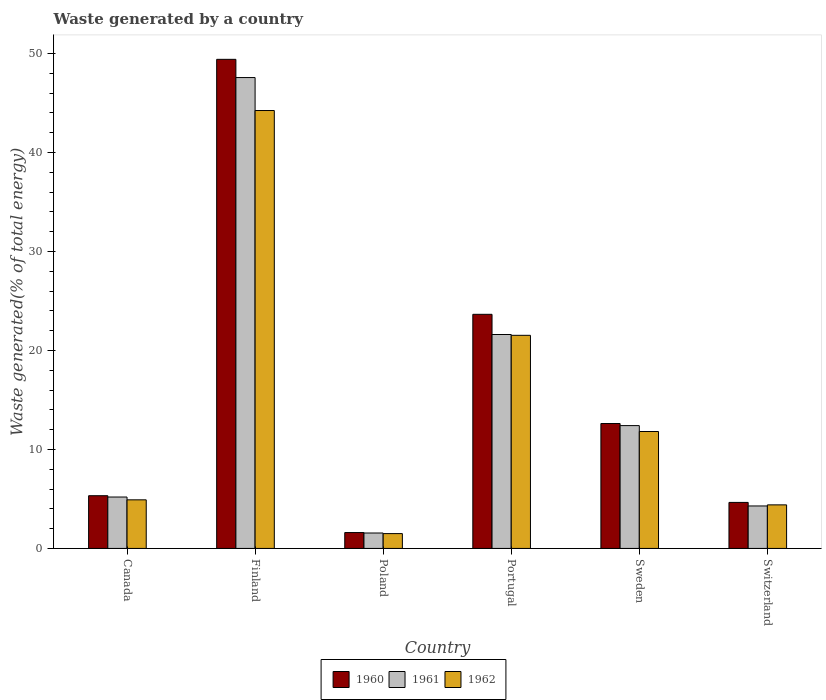How many different coloured bars are there?
Your response must be concise. 3. How many groups of bars are there?
Offer a terse response. 6. Are the number of bars per tick equal to the number of legend labels?
Provide a short and direct response. Yes. How many bars are there on the 2nd tick from the left?
Your answer should be very brief. 3. What is the label of the 1st group of bars from the left?
Ensure brevity in your answer.  Canada. In how many cases, is the number of bars for a given country not equal to the number of legend labels?
Your answer should be very brief. 0. What is the total waste generated in 1961 in Poland?
Offer a very short reply. 1.56. Across all countries, what is the maximum total waste generated in 1961?
Ensure brevity in your answer.  47.58. Across all countries, what is the minimum total waste generated in 1960?
Offer a terse response. 1.6. In which country was the total waste generated in 1961 maximum?
Offer a terse response. Finland. In which country was the total waste generated in 1962 minimum?
Give a very brief answer. Poland. What is the total total waste generated in 1962 in the graph?
Offer a very short reply. 88.41. What is the difference between the total waste generated in 1961 in Finland and that in Portugal?
Provide a succinct answer. 25.96. What is the difference between the total waste generated in 1960 in Poland and the total waste generated in 1962 in Switzerland?
Keep it short and to the point. -2.8. What is the average total waste generated in 1961 per country?
Provide a succinct answer. 15.44. What is the difference between the total waste generated of/in 1961 and total waste generated of/in 1960 in Sweden?
Make the answer very short. -0.21. What is the ratio of the total waste generated in 1961 in Canada to that in Portugal?
Your response must be concise. 0.24. What is the difference between the highest and the second highest total waste generated in 1961?
Your answer should be very brief. -9.2. What is the difference between the highest and the lowest total waste generated in 1962?
Ensure brevity in your answer.  42.75. In how many countries, is the total waste generated in 1962 greater than the average total waste generated in 1962 taken over all countries?
Give a very brief answer. 2. What does the 3rd bar from the left in Canada represents?
Offer a very short reply. 1962. What does the 2nd bar from the right in Canada represents?
Ensure brevity in your answer.  1961. Is it the case that in every country, the sum of the total waste generated in 1960 and total waste generated in 1961 is greater than the total waste generated in 1962?
Provide a succinct answer. Yes. How many bars are there?
Make the answer very short. 18. Are all the bars in the graph horizontal?
Offer a very short reply. No. How many countries are there in the graph?
Ensure brevity in your answer.  6. What is the difference between two consecutive major ticks on the Y-axis?
Give a very brief answer. 10. Are the values on the major ticks of Y-axis written in scientific E-notation?
Ensure brevity in your answer.  No. Does the graph contain any zero values?
Your answer should be compact. No. What is the title of the graph?
Provide a short and direct response. Waste generated by a country. Does "2006" appear as one of the legend labels in the graph?
Ensure brevity in your answer.  No. What is the label or title of the X-axis?
Your response must be concise. Country. What is the label or title of the Y-axis?
Keep it short and to the point. Waste generated(% of total energy). What is the Waste generated(% of total energy) of 1960 in Canada?
Your answer should be compact. 5.33. What is the Waste generated(% of total energy) in 1961 in Canada?
Offer a terse response. 5.19. What is the Waste generated(% of total energy) of 1962 in Canada?
Provide a succinct answer. 4.91. What is the Waste generated(% of total energy) in 1960 in Finland?
Your answer should be compact. 49.42. What is the Waste generated(% of total energy) of 1961 in Finland?
Offer a terse response. 47.58. What is the Waste generated(% of total energy) in 1962 in Finland?
Keep it short and to the point. 44.25. What is the Waste generated(% of total energy) in 1960 in Poland?
Ensure brevity in your answer.  1.6. What is the Waste generated(% of total energy) of 1961 in Poland?
Make the answer very short. 1.56. What is the Waste generated(% of total energy) in 1962 in Poland?
Keep it short and to the point. 1.5. What is the Waste generated(% of total energy) in 1960 in Portugal?
Give a very brief answer. 23.66. What is the Waste generated(% of total energy) in 1961 in Portugal?
Provide a succinct answer. 21.62. What is the Waste generated(% of total energy) of 1962 in Portugal?
Give a very brief answer. 21.53. What is the Waste generated(% of total energy) in 1960 in Sweden?
Provide a short and direct response. 12.62. What is the Waste generated(% of total energy) in 1961 in Sweden?
Offer a terse response. 12.41. What is the Waste generated(% of total energy) of 1962 in Sweden?
Ensure brevity in your answer.  11.82. What is the Waste generated(% of total energy) in 1960 in Switzerland?
Offer a terse response. 4.65. What is the Waste generated(% of total energy) in 1961 in Switzerland?
Provide a succinct answer. 4.29. What is the Waste generated(% of total energy) in 1962 in Switzerland?
Your answer should be very brief. 4.4. Across all countries, what is the maximum Waste generated(% of total energy) in 1960?
Your answer should be very brief. 49.42. Across all countries, what is the maximum Waste generated(% of total energy) of 1961?
Your answer should be very brief. 47.58. Across all countries, what is the maximum Waste generated(% of total energy) in 1962?
Your answer should be very brief. 44.25. Across all countries, what is the minimum Waste generated(% of total energy) in 1960?
Your answer should be very brief. 1.6. Across all countries, what is the minimum Waste generated(% of total energy) in 1961?
Ensure brevity in your answer.  1.56. Across all countries, what is the minimum Waste generated(% of total energy) of 1962?
Your response must be concise. 1.5. What is the total Waste generated(% of total energy) in 1960 in the graph?
Give a very brief answer. 97.28. What is the total Waste generated(% of total energy) of 1961 in the graph?
Make the answer very short. 92.66. What is the total Waste generated(% of total energy) in 1962 in the graph?
Offer a terse response. 88.41. What is the difference between the Waste generated(% of total energy) in 1960 in Canada and that in Finland?
Provide a short and direct response. -44.1. What is the difference between the Waste generated(% of total energy) of 1961 in Canada and that in Finland?
Provide a succinct answer. -42.39. What is the difference between the Waste generated(% of total energy) of 1962 in Canada and that in Finland?
Make the answer very short. -39.34. What is the difference between the Waste generated(% of total energy) of 1960 in Canada and that in Poland?
Provide a short and direct response. 3.72. What is the difference between the Waste generated(% of total energy) of 1961 in Canada and that in Poland?
Provide a succinct answer. 3.64. What is the difference between the Waste generated(% of total energy) of 1962 in Canada and that in Poland?
Keep it short and to the point. 3.41. What is the difference between the Waste generated(% of total energy) in 1960 in Canada and that in Portugal?
Your response must be concise. -18.33. What is the difference between the Waste generated(% of total energy) in 1961 in Canada and that in Portugal?
Offer a very short reply. -16.42. What is the difference between the Waste generated(% of total energy) of 1962 in Canada and that in Portugal?
Your answer should be compact. -16.62. What is the difference between the Waste generated(% of total energy) in 1960 in Canada and that in Sweden?
Your answer should be compact. -7.29. What is the difference between the Waste generated(% of total energy) in 1961 in Canada and that in Sweden?
Provide a short and direct response. -7.22. What is the difference between the Waste generated(% of total energy) in 1962 in Canada and that in Sweden?
Provide a short and direct response. -6.9. What is the difference between the Waste generated(% of total energy) of 1960 in Canada and that in Switzerland?
Your answer should be very brief. 0.68. What is the difference between the Waste generated(% of total energy) in 1961 in Canada and that in Switzerland?
Make the answer very short. 0.9. What is the difference between the Waste generated(% of total energy) of 1962 in Canada and that in Switzerland?
Your response must be concise. 0.51. What is the difference between the Waste generated(% of total energy) of 1960 in Finland and that in Poland?
Offer a terse response. 47.82. What is the difference between the Waste generated(% of total energy) in 1961 in Finland and that in Poland?
Keep it short and to the point. 46.02. What is the difference between the Waste generated(% of total energy) in 1962 in Finland and that in Poland?
Your answer should be compact. 42.75. What is the difference between the Waste generated(% of total energy) of 1960 in Finland and that in Portugal?
Keep it short and to the point. 25.77. What is the difference between the Waste generated(% of total energy) in 1961 in Finland and that in Portugal?
Keep it short and to the point. 25.96. What is the difference between the Waste generated(% of total energy) in 1962 in Finland and that in Portugal?
Make the answer very short. 22.72. What is the difference between the Waste generated(% of total energy) of 1960 in Finland and that in Sweden?
Provide a short and direct response. 36.8. What is the difference between the Waste generated(% of total energy) of 1961 in Finland and that in Sweden?
Provide a succinct answer. 35.17. What is the difference between the Waste generated(% of total energy) of 1962 in Finland and that in Sweden?
Your answer should be very brief. 32.44. What is the difference between the Waste generated(% of total energy) in 1960 in Finland and that in Switzerland?
Your answer should be very brief. 44.77. What is the difference between the Waste generated(% of total energy) of 1961 in Finland and that in Switzerland?
Give a very brief answer. 43.29. What is the difference between the Waste generated(% of total energy) of 1962 in Finland and that in Switzerland?
Keep it short and to the point. 39.85. What is the difference between the Waste generated(% of total energy) of 1960 in Poland and that in Portugal?
Your response must be concise. -22.05. What is the difference between the Waste generated(% of total energy) of 1961 in Poland and that in Portugal?
Ensure brevity in your answer.  -20.06. What is the difference between the Waste generated(% of total energy) in 1962 in Poland and that in Portugal?
Provide a succinct answer. -20.03. What is the difference between the Waste generated(% of total energy) in 1960 in Poland and that in Sweden?
Ensure brevity in your answer.  -11.02. What is the difference between the Waste generated(% of total energy) in 1961 in Poland and that in Sweden?
Ensure brevity in your answer.  -10.85. What is the difference between the Waste generated(% of total energy) in 1962 in Poland and that in Sweden?
Keep it short and to the point. -10.32. What is the difference between the Waste generated(% of total energy) in 1960 in Poland and that in Switzerland?
Your answer should be compact. -3.04. What is the difference between the Waste generated(% of total energy) of 1961 in Poland and that in Switzerland?
Give a very brief answer. -2.73. What is the difference between the Waste generated(% of total energy) of 1962 in Poland and that in Switzerland?
Ensure brevity in your answer.  -2.9. What is the difference between the Waste generated(% of total energy) of 1960 in Portugal and that in Sweden?
Offer a very short reply. 11.03. What is the difference between the Waste generated(% of total energy) of 1961 in Portugal and that in Sweden?
Make the answer very short. 9.2. What is the difference between the Waste generated(% of total energy) of 1962 in Portugal and that in Sweden?
Give a very brief answer. 9.72. What is the difference between the Waste generated(% of total energy) in 1960 in Portugal and that in Switzerland?
Provide a succinct answer. 19.01. What is the difference between the Waste generated(% of total energy) in 1961 in Portugal and that in Switzerland?
Make the answer very short. 17.32. What is the difference between the Waste generated(% of total energy) of 1962 in Portugal and that in Switzerland?
Give a very brief answer. 17.13. What is the difference between the Waste generated(% of total energy) in 1960 in Sweden and that in Switzerland?
Your answer should be compact. 7.97. What is the difference between the Waste generated(% of total energy) in 1961 in Sweden and that in Switzerland?
Your response must be concise. 8.12. What is the difference between the Waste generated(% of total energy) of 1962 in Sweden and that in Switzerland?
Provide a succinct answer. 7.41. What is the difference between the Waste generated(% of total energy) of 1960 in Canada and the Waste generated(% of total energy) of 1961 in Finland?
Your answer should be compact. -42.25. What is the difference between the Waste generated(% of total energy) in 1960 in Canada and the Waste generated(% of total energy) in 1962 in Finland?
Provide a succinct answer. -38.92. What is the difference between the Waste generated(% of total energy) in 1961 in Canada and the Waste generated(% of total energy) in 1962 in Finland?
Give a very brief answer. -39.06. What is the difference between the Waste generated(% of total energy) in 1960 in Canada and the Waste generated(% of total energy) in 1961 in Poland?
Offer a terse response. 3.77. What is the difference between the Waste generated(% of total energy) in 1960 in Canada and the Waste generated(% of total energy) in 1962 in Poland?
Offer a terse response. 3.83. What is the difference between the Waste generated(% of total energy) in 1961 in Canada and the Waste generated(% of total energy) in 1962 in Poland?
Make the answer very short. 3.7. What is the difference between the Waste generated(% of total energy) in 1960 in Canada and the Waste generated(% of total energy) in 1961 in Portugal?
Provide a short and direct response. -16.29. What is the difference between the Waste generated(% of total energy) in 1960 in Canada and the Waste generated(% of total energy) in 1962 in Portugal?
Offer a very short reply. -16.21. What is the difference between the Waste generated(% of total energy) of 1961 in Canada and the Waste generated(% of total energy) of 1962 in Portugal?
Offer a terse response. -16.34. What is the difference between the Waste generated(% of total energy) of 1960 in Canada and the Waste generated(% of total energy) of 1961 in Sweden?
Offer a terse response. -7.08. What is the difference between the Waste generated(% of total energy) in 1960 in Canada and the Waste generated(% of total energy) in 1962 in Sweden?
Provide a succinct answer. -6.49. What is the difference between the Waste generated(% of total energy) of 1961 in Canada and the Waste generated(% of total energy) of 1962 in Sweden?
Make the answer very short. -6.62. What is the difference between the Waste generated(% of total energy) in 1960 in Canada and the Waste generated(% of total energy) in 1961 in Switzerland?
Make the answer very short. 1.04. What is the difference between the Waste generated(% of total energy) in 1960 in Canada and the Waste generated(% of total energy) in 1962 in Switzerland?
Offer a terse response. 0.93. What is the difference between the Waste generated(% of total energy) in 1961 in Canada and the Waste generated(% of total energy) in 1962 in Switzerland?
Your response must be concise. 0.79. What is the difference between the Waste generated(% of total energy) of 1960 in Finland and the Waste generated(% of total energy) of 1961 in Poland?
Offer a terse response. 47.86. What is the difference between the Waste generated(% of total energy) of 1960 in Finland and the Waste generated(% of total energy) of 1962 in Poland?
Ensure brevity in your answer.  47.92. What is the difference between the Waste generated(% of total energy) of 1961 in Finland and the Waste generated(% of total energy) of 1962 in Poland?
Ensure brevity in your answer.  46.08. What is the difference between the Waste generated(% of total energy) of 1960 in Finland and the Waste generated(% of total energy) of 1961 in Portugal?
Your response must be concise. 27.81. What is the difference between the Waste generated(% of total energy) in 1960 in Finland and the Waste generated(% of total energy) in 1962 in Portugal?
Offer a terse response. 27.89. What is the difference between the Waste generated(% of total energy) in 1961 in Finland and the Waste generated(% of total energy) in 1962 in Portugal?
Your answer should be compact. 26.05. What is the difference between the Waste generated(% of total energy) of 1960 in Finland and the Waste generated(% of total energy) of 1961 in Sweden?
Ensure brevity in your answer.  37.01. What is the difference between the Waste generated(% of total energy) of 1960 in Finland and the Waste generated(% of total energy) of 1962 in Sweden?
Provide a succinct answer. 37.61. What is the difference between the Waste generated(% of total energy) in 1961 in Finland and the Waste generated(% of total energy) in 1962 in Sweden?
Offer a terse response. 35.77. What is the difference between the Waste generated(% of total energy) of 1960 in Finland and the Waste generated(% of total energy) of 1961 in Switzerland?
Ensure brevity in your answer.  45.13. What is the difference between the Waste generated(% of total energy) of 1960 in Finland and the Waste generated(% of total energy) of 1962 in Switzerland?
Your response must be concise. 45.02. What is the difference between the Waste generated(% of total energy) in 1961 in Finland and the Waste generated(% of total energy) in 1962 in Switzerland?
Offer a very short reply. 43.18. What is the difference between the Waste generated(% of total energy) of 1960 in Poland and the Waste generated(% of total energy) of 1961 in Portugal?
Give a very brief answer. -20.01. What is the difference between the Waste generated(% of total energy) in 1960 in Poland and the Waste generated(% of total energy) in 1962 in Portugal?
Offer a very short reply. -19.93. What is the difference between the Waste generated(% of total energy) of 1961 in Poland and the Waste generated(% of total energy) of 1962 in Portugal?
Provide a short and direct response. -19.98. What is the difference between the Waste generated(% of total energy) in 1960 in Poland and the Waste generated(% of total energy) in 1961 in Sweden?
Provide a short and direct response. -10.81. What is the difference between the Waste generated(% of total energy) of 1960 in Poland and the Waste generated(% of total energy) of 1962 in Sweden?
Your response must be concise. -10.21. What is the difference between the Waste generated(% of total energy) of 1961 in Poland and the Waste generated(% of total energy) of 1962 in Sweden?
Keep it short and to the point. -10.26. What is the difference between the Waste generated(% of total energy) of 1960 in Poland and the Waste generated(% of total energy) of 1961 in Switzerland?
Offer a very short reply. -2.69. What is the difference between the Waste generated(% of total energy) in 1960 in Poland and the Waste generated(% of total energy) in 1962 in Switzerland?
Offer a terse response. -2.8. What is the difference between the Waste generated(% of total energy) in 1961 in Poland and the Waste generated(% of total energy) in 1962 in Switzerland?
Offer a very short reply. -2.84. What is the difference between the Waste generated(% of total energy) in 1960 in Portugal and the Waste generated(% of total energy) in 1961 in Sweden?
Offer a very short reply. 11.24. What is the difference between the Waste generated(% of total energy) of 1960 in Portugal and the Waste generated(% of total energy) of 1962 in Sweden?
Offer a terse response. 11.84. What is the difference between the Waste generated(% of total energy) in 1961 in Portugal and the Waste generated(% of total energy) in 1962 in Sweden?
Ensure brevity in your answer.  9.8. What is the difference between the Waste generated(% of total energy) in 1960 in Portugal and the Waste generated(% of total energy) in 1961 in Switzerland?
Ensure brevity in your answer.  19.36. What is the difference between the Waste generated(% of total energy) of 1960 in Portugal and the Waste generated(% of total energy) of 1962 in Switzerland?
Provide a succinct answer. 19.25. What is the difference between the Waste generated(% of total energy) of 1961 in Portugal and the Waste generated(% of total energy) of 1962 in Switzerland?
Give a very brief answer. 17.21. What is the difference between the Waste generated(% of total energy) in 1960 in Sweden and the Waste generated(% of total energy) in 1961 in Switzerland?
Your answer should be compact. 8.33. What is the difference between the Waste generated(% of total energy) in 1960 in Sweden and the Waste generated(% of total energy) in 1962 in Switzerland?
Offer a very short reply. 8.22. What is the difference between the Waste generated(% of total energy) in 1961 in Sweden and the Waste generated(% of total energy) in 1962 in Switzerland?
Provide a short and direct response. 8.01. What is the average Waste generated(% of total energy) of 1960 per country?
Offer a very short reply. 16.21. What is the average Waste generated(% of total energy) of 1961 per country?
Provide a succinct answer. 15.44. What is the average Waste generated(% of total energy) of 1962 per country?
Give a very brief answer. 14.74. What is the difference between the Waste generated(% of total energy) in 1960 and Waste generated(% of total energy) in 1961 in Canada?
Offer a terse response. 0.13. What is the difference between the Waste generated(% of total energy) of 1960 and Waste generated(% of total energy) of 1962 in Canada?
Ensure brevity in your answer.  0.42. What is the difference between the Waste generated(% of total energy) of 1961 and Waste generated(% of total energy) of 1962 in Canada?
Provide a short and direct response. 0.28. What is the difference between the Waste generated(% of total energy) in 1960 and Waste generated(% of total energy) in 1961 in Finland?
Offer a terse response. 1.84. What is the difference between the Waste generated(% of total energy) in 1960 and Waste generated(% of total energy) in 1962 in Finland?
Offer a very short reply. 5.17. What is the difference between the Waste generated(% of total energy) in 1961 and Waste generated(% of total energy) in 1962 in Finland?
Give a very brief answer. 3.33. What is the difference between the Waste generated(% of total energy) in 1960 and Waste generated(% of total energy) in 1961 in Poland?
Offer a terse response. 0.05. What is the difference between the Waste generated(% of total energy) of 1960 and Waste generated(% of total energy) of 1962 in Poland?
Provide a short and direct response. 0.11. What is the difference between the Waste generated(% of total energy) of 1961 and Waste generated(% of total energy) of 1962 in Poland?
Your answer should be very brief. 0.06. What is the difference between the Waste generated(% of total energy) in 1960 and Waste generated(% of total energy) in 1961 in Portugal?
Your answer should be very brief. 2.04. What is the difference between the Waste generated(% of total energy) of 1960 and Waste generated(% of total energy) of 1962 in Portugal?
Offer a terse response. 2.12. What is the difference between the Waste generated(% of total energy) in 1961 and Waste generated(% of total energy) in 1962 in Portugal?
Keep it short and to the point. 0.08. What is the difference between the Waste generated(% of total energy) of 1960 and Waste generated(% of total energy) of 1961 in Sweden?
Offer a very short reply. 0.21. What is the difference between the Waste generated(% of total energy) in 1960 and Waste generated(% of total energy) in 1962 in Sweden?
Give a very brief answer. 0.81. What is the difference between the Waste generated(% of total energy) of 1961 and Waste generated(% of total energy) of 1962 in Sweden?
Make the answer very short. 0.6. What is the difference between the Waste generated(% of total energy) of 1960 and Waste generated(% of total energy) of 1961 in Switzerland?
Your answer should be compact. 0.36. What is the difference between the Waste generated(% of total energy) of 1960 and Waste generated(% of total energy) of 1962 in Switzerland?
Your answer should be very brief. 0.25. What is the difference between the Waste generated(% of total energy) in 1961 and Waste generated(% of total energy) in 1962 in Switzerland?
Offer a terse response. -0.11. What is the ratio of the Waste generated(% of total energy) of 1960 in Canada to that in Finland?
Provide a succinct answer. 0.11. What is the ratio of the Waste generated(% of total energy) in 1961 in Canada to that in Finland?
Offer a terse response. 0.11. What is the ratio of the Waste generated(% of total energy) of 1962 in Canada to that in Finland?
Offer a very short reply. 0.11. What is the ratio of the Waste generated(% of total energy) of 1960 in Canada to that in Poland?
Keep it short and to the point. 3.32. What is the ratio of the Waste generated(% of total energy) of 1961 in Canada to that in Poland?
Provide a succinct answer. 3.33. What is the ratio of the Waste generated(% of total energy) of 1962 in Canada to that in Poland?
Your response must be concise. 3.28. What is the ratio of the Waste generated(% of total energy) of 1960 in Canada to that in Portugal?
Make the answer very short. 0.23. What is the ratio of the Waste generated(% of total energy) in 1961 in Canada to that in Portugal?
Provide a succinct answer. 0.24. What is the ratio of the Waste generated(% of total energy) in 1962 in Canada to that in Portugal?
Ensure brevity in your answer.  0.23. What is the ratio of the Waste generated(% of total energy) of 1960 in Canada to that in Sweden?
Offer a terse response. 0.42. What is the ratio of the Waste generated(% of total energy) of 1961 in Canada to that in Sweden?
Give a very brief answer. 0.42. What is the ratio of the Waste generated(% of total energy) in 1962 in Canada to that in Sweden?
Keep it short and to the point. 0.42. What is the ratio of the Waste generated(% of total energy) in 1960 in Canada to that in Switzerland?
Your answer should be compact. 1.15. What is the ratio of the Waste generated(% of total energy) of 1961 in Canada to that in Switzerland?
Give a very brief answer. 1.21. What is the ratio of the Waste generated(% of total energy) of 1962 in Canada to that in Switzerland?
Make the answer very short. 1.12. What is the ratio of the Waste generated(% of total energy) of 1960 in Finland to that in Poland?
Offer a very short reply. 30.8. What is the ratio of the Waste generated(% of total energy) of 1961 in Finland to that in Poland?
Give a very brief answer. 30.53. What is the ratio of the Waste generated(% of total energy) in 1962 in Finland to that in Poland?
Offer a very short reply. 29.52. What is the ratio of the Waste generated(% of total energy) of 1960 in Finland to that in Portugal?
Give a very brief answer. 2.09. What is the ratio of the Waste generated(% of total energy) of 1961 in Finland to that in Portugal?
Provide a succinct answer. 2.2. What is the ratio of the Waste generated(% of total energy) of 1962 in Finland to that in Portugal?
Your answer should be compact. 2.05. What is the ratio of the Waste generated(% of total energy) in 1960 in Finland to that in Sweden?
Keep it short and to the point. 3.92. What is the ratio of the Waste generated(% of total energy) of 1961 in Finland to that in Sweden?
Provide a short and direct response. 3.83. What is the ratio of the Waste generated(% of total energy) of 1962 in Finland to that in Sweden?
Make the answer very short. 3.75. What is the ratio of the Waste generated(% of total energy) of 1960 in Finland to that in Switzerland?
Make the answer very short. 10.63. What is the ratio of the Waste generated(% of total energy) in 1961 in Finland to that in Switzerland?
Your answer should be compact. 11.09. What is the ratio of the Waste generated(% of total energy) of 1962 in Finland to that in Switzerland?
Give a very brief answer. 10.05. What is the ratio of the Waste generated(% of total energy) of 1960 in Poland to that in Portugal?
Make the answer very short. 0.07. What is the ratio of the Waste generated(% of total energy) of 1961 in Poland to that in Portugal?
Provide a short and direct response. 0.07. What is the ratio of the Waste generated(% of total energy) of 1962 in Poland to that in Portugal?
Your answer should be very brief. 0.07. What is the ratio of the Waste generated(% of total energy) in 1960 in Poland to that in Sweden?
Ensure brevity in your answer.  0.13. What is the ratio of the Waste generated(% of total energy) in 1961 in Poland to that in Sweden?
Provide a succinct answer. 0.13. What is the ratio of the Waste generated(% of total energy) in 1962 in Poland to that in Sweden?
Your answer should be compact. 0.13. What is the ratio of the Waste generated(% of total energy) in 1960 in Poland to that in Switzerland?
Offer a terse response. 0.35. What is the ratio of the Waste generated(% of total energy) of 1961 in Poland to that in Switzerland?
Provide a succinct answer. 0.36. What is the ratio of the Waste generated(% of total energy) of 1962 in Poland to that in Switzerland?
Give a very brief answer. 0.34. What is the ratio of the Waste generated(% of total energy) of 1960 in Portugal to that in Sweden?
Keep it short and to the point. 1.87. What is the ratio of the Waste generated(% of total energy) in 1961 in Portugal to that in Sweden?
Offer a terse response. 1.74. What is the ratio of the Waste generated(% of total energy) of 1962 in Portugal to that in Sweden?
Your answer should be compact. 1.82. What is the ratio of the Waste generated(% of total energy) in 1960 in Portugal to that in Switzerland?
Give a very brief answer. 5.09. What is the ratio of the Waste generated(% of total energy) in 1961 in Portugal to that in Switzerland?
Offer a very short reply. 5.04. What is the ratio of the Waste generated(% of total energy) of 1962 in Portugal to that in Switzerland?
Your answer should be compact. 4.89. What is the ratio of the Waste generated(% of total energy) in 1960 in Sweden to that in Switzerland?
Offer a very short reply. 2.71. What is the ratio of the Waste generated(% of total energy) of 1961 in Sweden to that in Switzerland?
Provide a succinct answer. 2.89. What is the ratio of the Waste generated(% of total energy) in 1962 in Sweden to that in Switzerland?
Provide a succinct answer. 2.68. What is the difference between the highest and the second highest Waste generated(% of total energy) in 1960?
Your answer should be very brief. 25.77. What is the difference between the highest and the second highest Waste generated(% of total energy) of 1961?
Make the answer very short. 25.96. What is the difference between the highest and the second highest Waste generated(% of total energy) of 1962?
Your response must be concise. 22.72. What is the difference between the highest and the lowest Waste generated(% of total energy) of 1960?
Give a very brief answer. 47.82. What is the difference between the highest and the lowest Waste generated(% of total energy) in 1961?
Make the answer very short. 46.02. What is the difference between the highest and the lowest Waste generated(% of total energy) in 1962?
Provide a short and direct response. 42.75. 